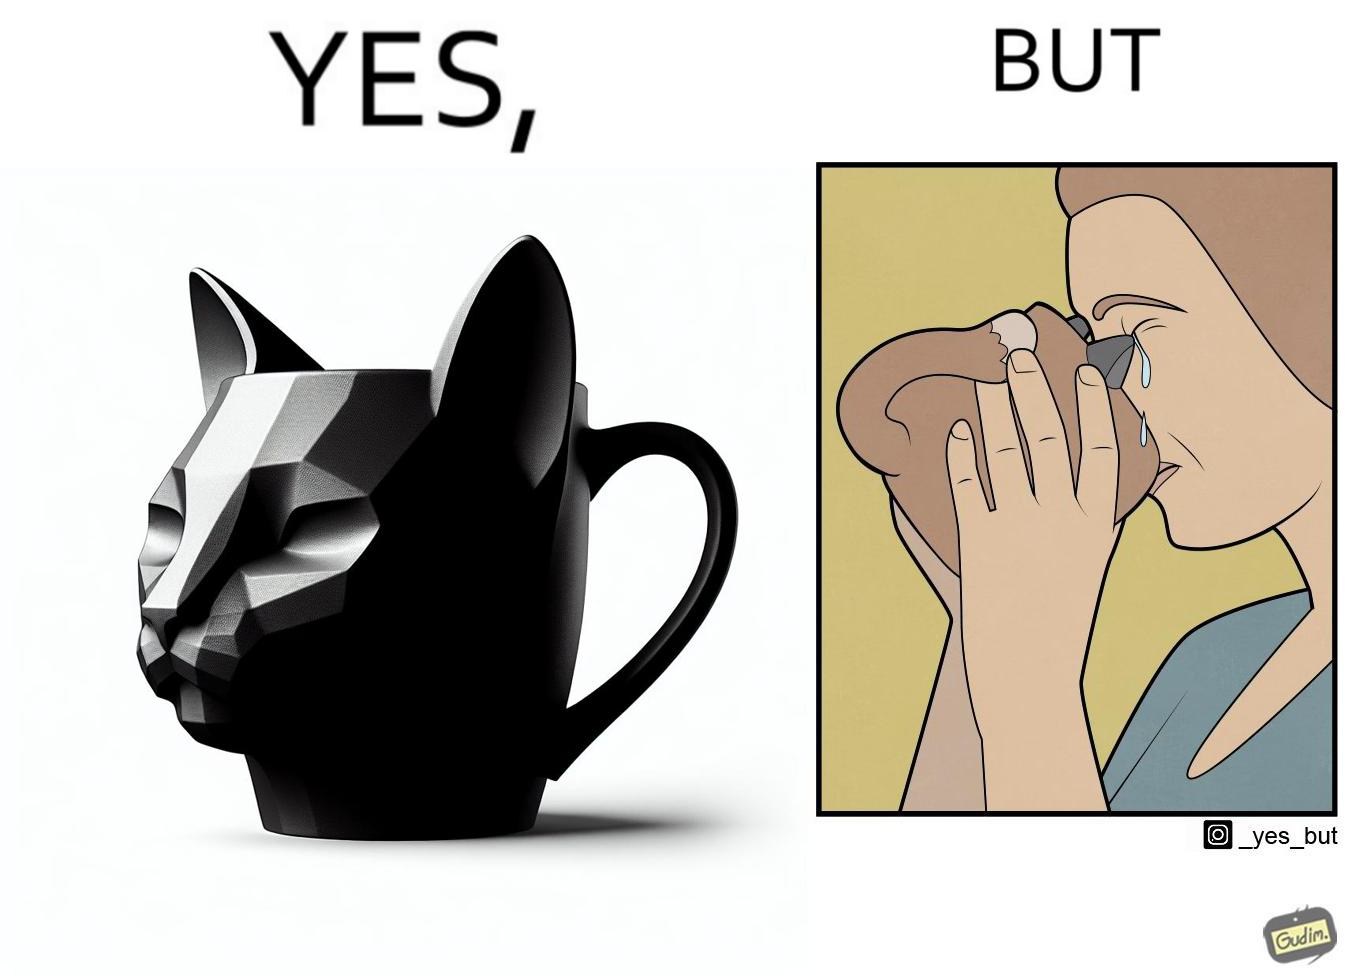Is this a satirical image? Yes, this image is satirical. 